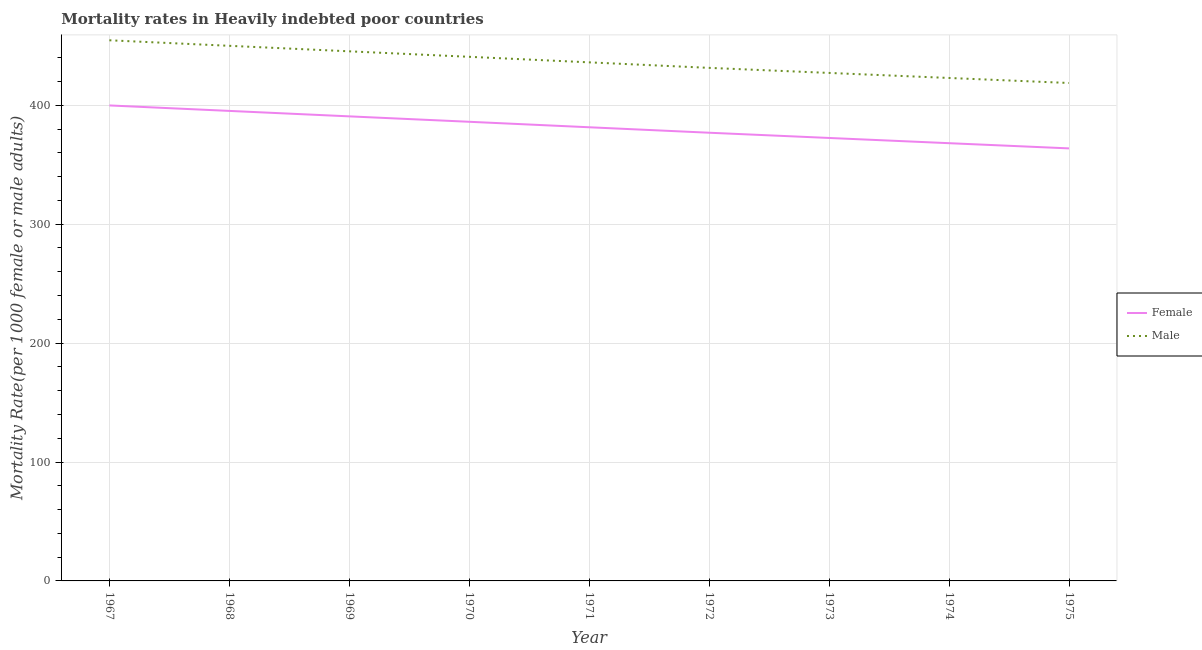Does the line corresponding to female mortality rate intersect with the line corresponding to male mortality rate?
Provide a succinct answer. No. Is the number of lines equal to the number of legend labels?
Keep it short and to the point. Yes. What is the female mortality rate in 1972?
Provide a short and direct response. 376.93. Across all years, what is the maximum female mortality rate?
Your answer should be compact. 399.88. Across all years, what is the minimum male mortality rate?
Give a very brief answer. 418.76. In which year was the male mortality rate maximum?
Your answer should be very brief. 1967. In which year was the male mortality rate minimum?
Offer a terse response. 1975. What is the total female mortality rate in the graph?
Offer a terse response. 3434.88. What is the difference between the female mortality rate in 1968 and that in 1975?
Keep it short and to the point. 31.52. What is the difference between the female mortality rate in 1974 and the male mortality rate in 1968?
Give a very brief answer. -81.89. What is the average male mortality rate per year?
Provide a succinct answer. 436.38. In the year 1968, what is the difference between the male mortality rate and female mortality rate?
Provide a short and direct response. 54.75. In how many years, is the male mortality rate greater than 380?
Your answer should be compact. 9. What is the ratio of the female mortality rate in 1970 to that in 1972?
Ensure brevity in your answer.  1.02. Is the difference between the female mortality rate in 1968 and 1974 greater than the difference between the male mortality rate in 1968 and 1974?
Provide a short and direct response. Yes. What is the difference between the highest and the second highest male mortality rate?
Provide a short and direct response. 4.65. What is the difference between the highest and the lowest male mortality rate?
Ensure brevity in your answer.  35.92. In how many years, is the female mortality rate greater than the average female mortality rate taken over all years?
Your answer should be compact. 4. Is the sum of the female mortality rate in 1969 and 1973 greater than the maximum male mortality rate across all years?
Your answer should be compact. Yes. Is the male mortality rate strictly greater than the female mortality rate over the years?
Provide a succinct answer. Yes. Is the female mortality rate strictly less than the male mortality rate over the years?
Provide a short and direct response. Yes. How many lines are there?
Ensure brevity in your answer.  2. How many years are there in the graph?
Ensure brevity in your answer.  9. Are the values on the major ticks of Y-axis written in scientific E-notation?
Provide a succinct answer. No. How are the legend labels stacked?
Your answer should be very brief. Vertical. What is the title of the graph?
Keep it short and to the point. Mortality rates in Heavily indebted poor countries. Does "Death rate" appear as one of the legend labels in the graph?
Ensure brevity in your answer.  No. What is the label or title of the X-axis?
Ensure brevity in your answer.  Year. What is the label or title of the Y-axis?
Give a very brief answer. Mortality Rate(per 1000 female or male adults). What is the Mortality Rate(per 1000 female or male adults) in Female in 1967?
Ensure brevity in your answer.  399.88. What is the Mortality Rate(per 1000 female or male adults) of Male in 1967?
Offer a very short reply. 454.68. What is the Mortality Rate(per 1000 female or male adults) in Female in 1968?
Your answer should be very brief. 395.28. What is the Mortality Rate(per 1000 female or male adults) of Male in 1968?
Offer a very short reply. 450.03. What is the Mortality Rate(per 1000 female or male adults) of Female in 1969?
Provide a short and direct response. 390.7. What is the Mortality Rate(per 1000 female or male adults) in Male in 1969?
Provide a short and direct response. 445.4. What is the Mortality Rate(per 1000 female or male adults) of Female in 1970?
Offer a terse response. 386.13. What is the Mortality Rate(per 1000 female or male adults) of Male in 1970?
Offer a terse response. 440.78. What is the Mortality Rate(per 1000 female or male adults) of Female in 1971?
Provide a succinct answer. 381.53. What is the Mortality Rate(per 1000 female or male adults) in Male in 1971?
Keep it short and to the point. 436.12. What is the Mortality Rate(per 1000 female or male adults) of Female in 1972?
Your answer should be compact. 376.93. What is the Mortality Rate(per 1000 female or male adults) of Male in 1972?
Provide a short and direct response. 431.48. What is the Mortality Rate(per 1000 female or male adults) in Female in 1973?
Provide a succinct answer. 372.53. What is the Mortality Rate(per 1000 female or male adults) of Male in 1973?
Keep it short and to the point. 427.22. What is the Mortality Rate(per 1000 female or male adults) of Female in 1974?
Offer a terse response. 368.14. What is the Mortality Rate(per 1000 female or male adults) in Male in 1974?
Provide a succinct answer. 422.99. What is the Mortality Rate(per 1000 female or male adults) of Female in 1975?
Offer a very short reply. 363.76. What is the Mortality Rate(per 1000 female or male adults) in Male in 1975?
Offer a terse response. 418.76. Across all years, what is the maximum Mortality Rate(per 1000 female or male adults) of Female?
Offer a terse response. 399.88. Across all years, what is the maximum Mortality Rate(per 1000 female or male adults) of Male?
Ensure brevity in your answer.  454.68. Across all years, what is the minimum Mortality Rate(per 1000 female or male adults) of Female?
Your answer should be compact. 363.76. Across all years, what is the minimum Mortality Rate(per 1000 female or male adults) of Male?
Ensure brevity in your answer.  418.76. What is the total Mortality Rate(per 1000 female or male adults) of Female in the graph?
Keep it short and to the point. 3434.88. What is the total Mortality Rate(per 1000 female or male adults) in Male in the graph?
Keep it short and to the point. 3927.45. What is the difference between the Mortality Rate(per 1000 female or male adults) in Male in 1967 and that in 1968?
Your response must be concise. 4.65. What is the difference between the Mortality Rate(per 1000 female or male adults) of Female in 1967 and that in 1969?
Ensure brevity in your answer.  9.18. What is the difference between the Mortality Rate(per 1000 female or male adults) in Male in 1967 and that in 1969?
Provide a succinct answer. 9.28. What is the difference between the Mortality Rate(per 1000 female or male adults) of Female in 1967 and that in 1970?
Your answer should be very brief. 13.75. What is the difference between the Mortality Rate(per 1000 female or male adults) in Male in 1967 and that in 1970?
Offer a very short reply. 13.9. What is the difference between the Mortality Rate(per 1000 female or male adults) of Female in 1967 and that in 1971?
Your response must be concise. 18.35. What is the difference between the Mortality Rate(per 1000 female or male adults) of Male in 1967 and that in 1971?
Offer a very short reply. 18.56. What is the difference between the Mortality Rate(per 1000 female or male adults) in Female in 1967 and that in 1972?
Make the answer very short. 22.95. What is the difference between the Mortality Rate(per 1000 female or male adults) in Male in 1967 and that in 1972?
Provide a succinct answer. 23.2. What is the difference between the Mortality Rate(per 1000 female or male adults) of Female in 1967 and that in 1973?
Provide a succinct answer. 27.35. What is the difference between the Mortality Rate(per 1000 female or male adults) of Male in 1967 and that in 1973?
Offer a very short reply. 27.45. What is the difference between the Mortality Rate(per 1000 female or male adults) of Female in 1967 and that in 1974?
Offer a terse response. 31.74. What is the difference between the Mortality Rate(per 1000 female or male adults) in Male in 1967 and that in 1974?
Offer a terse response. 31.69. What is the difference between the Mortality Rate(per 1000 female or male adults) in Female in 1967 and that in 1975?
Ensure brevity in your answer.  36.12. What is the difference between the Mortality Rate(per 1000 female or male adults) in Male in 1967 and that in 1975?
Ensure brevity in your answer.  35.92. What is the difference between the Mortality Rate(per 1000 female or male adults) in Female in 1968 and that in 1969?
Your answer should be compact. 4.58. What is the difference between the Mortality Rate(per 1000 female or male adults) in Male in 1968 and that in 1969?
Your response must be concise. 4.63. What is the difference between the Mortality Rate(per 1000 female or male adults) in Female in 1968 and that in 1970?
Ensure brevity in your answer.  9.15. What is the difference between the Mortality Rate(per 1000 female or male adults) of Male in 1968 and that in 1970?
Your response must be concise. 9.25. What is the difference between the Mortality Rate(per 1000 female or male adults) in Female in 1968 and that in 1971?
Provide a succinct answer. 13.75. What is the difference between the Mortality Rate(per 1000 female or male adults) of Male in 1968 and that in 1971?
Offer a very short reply. 13.9. What is the difference between the Mortality Rate(per 1000 female or male adults) of Female in 1968 and that in 1972?
Provide a short and direct response. 18.35. What is the difference between the Mortality Rate(per 1000 female or male adults) of Male in 1968 and that in 1972?
Make the answer very short. 18.55. What is the difference between the Mortality Rate(per 1000 female or male adults) of Female in 1968 and that in 1973?
Your answer should be very brief. 22.75. What is the difference between the Mortality Rate(per 1000 female or male adults) in Male in 1968 and that in 1973?
Provide a succinct answer. 22.8. What is the difference between the Mortality Rate(per 1000 female or male adults) in Female in 1968 and that in 1974?
Provide a short and direct response. 27.14. What is the difference between the Mortality Rate(per 1000 female or male adults) in Male in 1968 and that in 1974?
Your answer should be very brief. 27.04. What is the difference between the Mortality Rate(per 1000 female or male adults) in Female in 1968 and that in 1975?
Keep it short and to the point. 31.52. What is the difference between the Mortality Rate(per 1000 female or male adults) in Male in 1968 and that in 1975?
Offer a terse response. 31.27. What is the difference between the Mortality Rate(per 1000 female or male adults) in Female in 1969 and that in 1970?
Keep it short and to the point. 4.57. What is the difference between the Mortality Rate(per 1000 female or male adults) in Male in 1969 and that in 1970?
Provide a succinct answer. 4.61. What is the difference between the Mortality Rate(per 1000 female or male adults) in Female in 1969 and that in 1971?
Provide a succinct answer. 9.17. What is the difference between the Mortality Rate(per 1000 female or male adults) of Male in 1969 and that in 1971?
Provide a short and direct response. 9.27. What is the difference between the Mortality Rate(per 1000 female or male adults) in Female in 1969 and that in 1972?
Offer a terse response. 13.77. What is the difference between the Mortality Rate(per 1000 female or male adults) in Male in 1969 and that in 1972?
Your answer should be compact. 13.92. What is the difference between the Mortality Rate(per 1000 female or male adults) in Female in 1969 and that in 1973?
Ensure brevity in your answer.  18.17. What is the difference between the Mortality Rate(per 1000 female or male adults) of Male in 1969 and that in 1973?
Your answer should be very brief. 18.17. What is the difference between the Mortality Rate(per 1000 female or male adults) of Female in 1969 and that in 1974?
Provide a succinct answer. 22.56. What is the difference between the Mortality Rate(per 1000 female or male adults) of Male in 1969 and that in 1974?
Ensure brevity in your answer.  22.41. What is the difference between the Mortality Rate(per 1000 female or male adults) in Female in 1969 and that in 1975?
Offer a terse response. 26.94. What is the difference between the Mortality Rate(per 1000 female or male adults) of Male in 1969 and that in 1975?
Ensure brevity in your answer.  26.64. What is the difference between the Mortality Rate(per 1000 female or male adults) of Female in 1970 and that in 1971?
Give a very brief answer. 4.61. What is the difference between the Mortality Rate(per 1000 female or male adults) in Male in 1970 and that in 1971?
Give a very brief answer. 4.66. What is the difference between the Mortality Rate(per 1000 female or male adults) of Female in 1970 and that in 1972?
Offer a very short reply. 9.2. What is the difference between the Mortality Rate(per 1000 female or male adults) in Male in 1970 and that in 1972?
Offer a terse response. 9.3. What is the difference between the Mortality Rate(per 1000 female or male adults) of Female in 1970 and that in 1973?
Give a very brief answer. 13.6. What is the difference between the Mortality Rate(per 1000 female or male adults) of Male in 1970 and that in 1973?
Provide a short and direct response. 13.56. What is the difference between the Mortality Rate(per 1000 female or male adults) of Female in 1970 and that in 1974?
Provide a short and direct response. 17.99. What is the difference between the Mortality Rate(per 1000 female or male adults) in Male in 1970 and that in 1974?
Your answer should be very brief. 17.79. What is the difference between the Mortality Rate(per 1000 female or male adults) of Female in 1970 and that in 1975?
Provide a succinct answer. 22.38. What is the difference between the Mortality Rate(per 1000 female or male adults) of Male in 1970 and that in 1975?
Ensure brevity in your answer.  22.02. What is the difference between the Mortality Rate(per 1000 female or male adults) in Female in 1971 and that in 1972?
Provide a succinct answer. 4.59. What is the difference between the Mortality Rate(per 1000 female or male adults) in Male in 1971 and that in 1972?
Give a very brief answer. 4.64. What is the difference between the Mortality Rate(per 1000 female or male adults) in Female in 1971 and that in 1973?
Your response must be concise. 9. What is the difference between the Mortality Rate(per 1000 female or male adults) in Male in 1971 and that in 1973?
Your answer should be compact. 8.9. What is the difference between the Mortality Rate(per 1000 female or male adults) of Female in 1971 and that in 1974?
Offer a terse response. 13.39. What is the difference between the Mortality Rate(per 1000 female or male adults) of Male in 1971 and that in 1974?
Offer a terse response. 13.14. What is the difference between the Mortality Rate(per 1000 female or male adults) in Female in 1971 and that in 1975?
Your response must be concise. 17.77. What is the difference between the Mortality Rate(per 1000 female or male adults) in Male in 1971 and that in 1975?
Provide a short and direct response. 17.36. What is the difference between the Mortality Rate(per 1000 female or male adults) in Female in 1972 and that in 1973?
Keep it short and to the point. 4.4. What is the difference between the Mortality Rate(per 1000 female or male adults) in Male in 1972 and that in 1973?
Provide a short and direct response. 4.25. What is the difference between the Mortality Rate(per 1000 female or male adults) of Female in 1972 and that in 1974?
Make the answer very short. 8.79. What is the difference between the Mortality Rate(per 1000 female or male adults) in Male in 1972 and that in 1974?
Your answer should be compact. 8.49. What is the difference between the Mortality Rate(per 1000 female or male adults) in Female in 1972 and that in 1975?
Your answer should be very brief. 13.18. What is the difference between the Mortality Rate(per 1000 female or male adults) of Male in 1972 and that in 1975?
Your answer should be very brief. 12.72. What is the difference between the Mortality Rate(per 1000 female or male adults) in Female in 1973 and that in 1974?
Your answer should be very brief. 4.39. What is the difference between the Mortality Rate(per 1000 female or male adults) in Male in 1973 and that in 1974?
Give a very brief answer. 4.24. What is the difference between the Mortality Rate(per 1000 female or male adults) of Female in 1973 and that in 1975?
Make the answer very short. 8.77. What is the difference between the Mortality Rate(per 1000 female or male adults) of Male in 1973 and that in 1975?
Offer a terse response. 8.46. What is the difference between the Mortality Rate(per 1000 female or male adults) of Female in 1974 and that in 1975?
Your response must be concise. 4.38. What is the difference between the Mortality Rate(per 1000 female or male adults) in Male in 1974 and that in 1975?
Your answer should be very brief. 4.23. What is the difference between the Mortality Rate(per 1000 female or male adults) in Female in 1967 and the Mortality Rate(per 1000 female or male adults) in Male in 1968?
Give a very brief answer. -50.15. What is the difference between the Mortality Rate(per 1000 female or male adults) of Female in 1967 and the Mortality Rate(per 1000 female or male adults) of Male in 1969?
Give a very brief answer. -45.51. What is the difference between the Mortality Rate(per 1000 female or male adults) of Female in 1967 and the Mortality Rate(per 1000 female or male adults) of Male in 1970?
Your response must be concise. -40.9. What is the difference between the Mortality Rate(per 1000 female or male adults) in Female in 1967 and the Mortality Rate(per 1000 female or male adults) in Male in 1971?
Your answer should be compact. -36.24. What is the difference between the Mortality Rate(per 1000 female or male adults) of Female in 1967 and the Mortality Rate(per 1000 female or male adults) of Male in 1972?
Your answer should be very brief. -31.6. What is the difference between the Mortality Rate(per 1000 female or male adults) of Female in 1967 and the Mortality Rate(per 1000 female or male adults) of Male in 1973?
Provide a succinct answer. -27.34. What is the difference between the Mortality Rate(per 1000 female or male adults) in Female in 1967 and the Mortality Rate(per 1000 female or male adults) in Male in 1974?
Provide a succinct answer. -23.11. What is the difference between the Mortality Rate(per 1000 female or male adults) of Female in 1967 and the Mortality Rate(per 1000 female or male adults) of Male in 1975?
Keep it short and to the point. -18.88. What is the difference between the Mortality Rate(per 1000 female or male adults) of Female in 1968 and the Mortality Rate(per 1000 female or male adults) of Male in 1969?
Provide a succinct answer. -50.11. What is the difference between the Mortality Rate(per 1000 female or male adults) in Female in 1968 and the Mortality Rate(per 1000 female or male adults) in Male in 1970?
Your answer should be very brief. -45.5. What is the difference between the Mortality Rate(per 1000 female or male adults) of Female in 1968 and the Mortality Rate(per 1000 female or male adults) of Male in 1971?
Your answer should be very brief. -40.84. What is the difference between the Mortality Rate(per 1000 female or male adults) of Female in 1968 and the Mortality Rate(per 1000 female or male adults) of Male in 1972?
Make the answer very short. -36.2. What is the difference between the Mortality Rate(per 1000 female or male adults) in Female in 1968 and the Mortality Rate(per 1000 female or male adults) in Male in 1973?
Offer a terse response. -31.94. What is the difference between the Mortality Rate(per 1000 female or male adults) in Female in 1968 and the Mortality Rate(per 1000 female or male adults) in Male in 1974?
Your answer should be compact. -27.71. What is the difference between the Mortality Rate(per 1000 female or male adults) in Female in 1968 and the Mortality Rate(per 1000 female or male adults) in Male in 1975?
Give a very brief answer. -23.48. What is the difference between the Mortality Rate(per 1000 female or male adults) of Female in 1969 and the Mortality Rate(per 1000 female or male adults) of Male in 1970?
Give a very brief answer. -50.08. What is the difference between the Mortality Rate(per 1000 female or male adults) of Female in 1969 and the Mortality Rate(per 1000 female or male adults) of Male in 1971?
Offer a terse response. -45.42. What is the difference between the Mortality Rate(per 1000 female or male adults) of Female in 1969 and the Mortality Rate(per 1000 female or male adults) of Male in 1972?
Your answer should be very brief. -40.78. What is the difference between the Mortality Rate(per 1000 female or male adults) in Female in 1969 and the Mortality Rate(per 1000 female or male adults) in Male in 1973?
Offer a terse response. -36.53. What is the difference between the Mortality Rate(per 1000 female or male adults) of Female in 1969 and the Mortality Rate(per 1000 female or male adults) of Male in 1974?
Your response must be concise. -32.29. What is the difference between the Mortality Rate(per 1000 female or male adults) of Female in 1969 and the Mortality Rate(per 1000 female or male adults) of Male in 1975?
Provide a short and direct response. -28.06. What is the difference between the Mortality Rate(per 1000 female or male adults) in Female in 1970 and the Mortality Rate(per 1000 female or male adults) in Male in 1971?
Your answer should be compact. -49.99. What is the difference between the Mortality Rate(per 1000 female or male adults) of Female in 1970 and the Mortality Rate(per 1000 female or male adults) of Male in 1972?
Give a very brief answer. -45.35. What is the difference between the Mortality Rate(per 1000 female or male adults) in Female in 1970 and the Mortality Rate(per 1000 female or male adults) in Male in 1973?
Make the answer very short. -41.09. What is the difference between the Mortality Rate(per 1000 female or male adults) in Female in 1970 and the Mortality Rate(per 1000 female or male adults) in Male in 1974?
Your response must be concise. -36.85. What is the difference between the Mortality Rate(per 1000 female or male adults) of Female in 1970 and the Mortality Rate(per 1000 female or male adults) of Male in 1975?
Give a very brief answer. -32.63. What is the difference between the Mortality Rate(per 1000 female or male adults) of Female in 1971 and the Mortality Rate(per 1000 female or male adults) of Male in 1972?
Give a very brief answer. -49.95. What is the difference between the Mortality Rate(per 1000 female or male adults) of Female in 1971 and the Mortality Rate(per 1000 female or male adults) of Male in 1973?
Make the answer very short. -45.7. What is the difference between the Mortality Rate(per 1000 female or male adults) in Female in 1971 and the Mortality Rate(per 1000 female or male adults) in Male in 1974?
Make the answer very short. -41.46. What is the difference between the Mortality Rate(per 1000 female or male adults) in Female in 1971 and the Mortality Rate(per 1000 female or male adults) in Male in 1975?
Offer a terse response. -37.23. What is the difference between the Mortality Rate(per 1000 female or male adults) in Female in 1972 and the Mortality Rate(per 1000 female or male adults) in Male in 1973?
Offer a terse response. -50.29. What is the difference between the Mortality Rate(per 1000 female or male adults) in Female in 1972 and the Mortality Rate(per 1000 female or male adults) in Male in 1974?
Give a very brief answer. -46.05. What is the difference between the Mortality Rate(per 1000 female or male adults) of Female in 1972 and the Mortality Rate(per 1000 female or male adults) of Male in 1975?
Give a very brief answer. -41.83. What is the difference between the Mortality Rate(per 1000 female or male adults) of Female in 1973 and the Mortality Rate(per 1000 female or male adults) of Male in 1974?
Ensure brevity in your answer.  -50.46. What is the difference between the Mortality Rate(per 1000 female or male adults) in Female in 1973 and the Mortality Rate(per 1000 female or male adults) in Male in 1975?
Provide a short and direct response. -46.23. What is the difference between the Mortality Rate(per 1000 female or male adults) of Female in 1974 and the Mortality Rate(per 1000 female or male adults) of Male in 1975?
Your response must be concise. -50.62. What is the average Mortality Rate(per 1000 female or male adults) in Female per year?
Your answer should be compact. 381.65. What is the average Mortality Rate(per 1000 female or male adults) in Male per year?
Your answer should be compact. 436.38. In the year 1967, what is the difference between the Mortality Rate(per 1000 female or male adults) in Female and Mortality Rate(per 1000 female or male adults) in Male?
Make the answer very short. -54.8. In the year 1968, what is the difference between the Mortality Rate(per 1000 female or male adults) in Female and Mortality Rate(per 1000 female or male adults) in Male?
Keep it short and to the point. -54.75. In the year 1969, what is the difference between the Mortality Rate(per 1000 female or male adults) in Female and Mortality Rate(per 1000 female or male adults) in Male?
Your answer should be very brief. -54.7. In the year 1970, what is the difference between the Mortality Rate(per 1000 female or male adults) in Female and Mortality Rate(per 1000 female or male adults) in Male?
Provide a succinct answer. -54.65. In the year 1971, what is the difference between the Mortality Rate(per 1000 female or male adults) of Female and Mortality Rate(per 1000 female or male adults) of Male?
Ensure brevity in your answer.  -54.6. In the year 1972, what is the difference between the Mortality Rate(per 1000 female or male adults) in Female and Mortality Rate(per 1000 female or male adults) in Male?
Your answer should be compact. -54.55. In the year 1973, what is the difference between the Mortality Rate(per 1000 female or male adults) of Female and Mortality Rate(per 1000 female or male adults) of Male?
Your answer should be compact. -54.69. In the year 1974, what is the difference between the Mortality Rate(per 1000 female or male adults) of Female and Mortality Rate(per 1000 female or male adults) of Male?
Give a very brief answer. -54.85. In the year 1975, what is the difference between the Mortality Rate(per 1000 female or male adults) in Female and Mortality Rate(per 1000 female or male adults) in Male?
Keep it short and to the point. -55. What is the ratio of the Mortality Rate(per 1000 female or male adults) of Female in 1967 to that in 1968?
Ensure brevity in your answer.  1.01. What is the ratio of the Mortality Rate(per 1000 female or male adults) of Male in 1967 to that in 1968?
Your answer should be very brief. 1.01. What is the ratio of the Mortality Rate(per 1000 female or male adults) of Female in 1967 to that in 1969?
Give a very brief answer. 1.02. What is the ratio of the Mortality Rate(per 1000 female or male adults) in Male in 1967 to that in 1969?
Ensure brevity in your answer.  1.02. What is the ratio of the Mortality Rate(per 1000 female or male adults) in Female in 1967 to that in 1970?
Provide a succinct answer. 1.04. What is the ratio of the Mortality Rate(per 1000 female or male adults) of Male in 1967 to that in 1970?
Make the answer very short. 1.03. What is the ratio of the Mortality Rate(per 1000 female or male adults) of Female in 1967 to that in 1971?
Ensure brevity in your answer.  1.05. What is the ratio of the Mortality Rate(per 1000 female or male adults) of Male in 1967 to that in 1971?
Your answer should be very brief. 1.04. What is the ratio of the Mortality Rate(per 1000 female or male adults) of Female in 1967 to that in 1972?
Give a very brief answer. 1.06. What is the ratio of the Mortality Rate(per 1000 female or male adults) of Male in 1967 to that in 1972?
Your answer should be very brief. 1.05. What is the ratio of the Mortality Rate(per 1000 female or male adults) of Female in 1967 to that in 1973?
Offer a very short reply. 1.07. What is the ratio of the Mortality Rate(per 1000 female or male adults) of Male in 1967 to that in 1973?
Provide a succinct answer. 1.06. What is the ratio of the Mortality Rate(per 1000 female or male adults) of Female in 1967 to that in 1974?
Keep it short and to the point. 1.09. What is the ratio of the Mortality Rate(per 1000 female or male adults) in Male in 1967 to that in 1974?
Your response must be concise. 1.07. What is the ratio of the Mortality Rate(per 1000 female or male adults) in Female in 1967 to that in 1975?
Your answer should be very brief. 1.1. What is the ratio of the Mortality Rate(per 1000 female or male adults) in Male in 1967 to that in 1975?
Provide a short and direct response. 1.09. What is the ratio of the Mortality Rate(per 1000 female or male adults) of Female in 1968 to that in 1969?
Keep it short and to the point. 1.01. What is the ratio of the Mortality Rate(per 1000 female or male adults) in Male in 1968 to that in 1969?
Give a very brief answer. 1.01. What is the ratio of the Mortality Rate(per 1000 female or male adults) in Female in 1968 to that in 1970?
Offer a very short reply. 1.02. What is the ratio of the Mortality Rate(per 1000 female or male adults) in Male in 1968 to that in 1970?
Your answer should be compact. 1.02. What is the ratio of the Mortality Rate(per 1000 female or male adults) of Female in 1968 to that in 1971?
Provide a succinct answer. 1.04. What is the ratio of the Mortality Rate(per 1000 female or male adults) in Male in 1968 to that in 1971?
Offer a terse response. 1.03. What is the ratio of the Mortality Rate(per 1000 female or male adults) of Female in 1968 to that in 1972?
Make the answer very short. 1.05. What is the ratio of the Mortality Rate(per 1000 female or male adults) in Male in 1968 to that in 1972?
Offer a very short reply. 1.04. What is the ratio of the Mortality Rate(per 1000 female or male adults) of Female in 1968 to that in 1973?
Your response must be concise. 1.06. What is the ratio of the Mortality Rate(per 1000 female or male adults) of Male in 1968 to that in 1973?
Your response must be concise. 1.05. What is the ratio of the Mortality Rate(per 1000 female or male adults) in Female in 1968 to that in 1974?
Offer a very short reply. 1.07. What is the ratio of the Mortality Rate(per 1000 female or male adults) in Male in 1968 to that in 1974?
Give a very brief answer. 1.06. What is the ratio of the Mortality Rate(per 1000 female or male adults) in Female in 1968 to that in 1975?
Make the answer very short. 1.09. What is the ratio of the Mortality Rate(per 1000 female or male adults) in Male in 1968 to that in 1975?
Keep it short and to the point. 1.07. What is the ratio of the Mortality Rate(per 1000 female or male adults) in Female in 1969 to that in 1970?
Provide a succinct answer. 1.01. What is the ratio of the Mortality Rate(per 1000 female or male adults) in Male in 1969 to that in 1970?
Your answer should be very brief. 1.01. What is the ratio of the Mortality Rate(per 1000 female or male adults) in Female in 1969 to that in 1971?
Your answer should be very brief. 1.02. What is the ratio of the Mortality Rate(per 1000 female or male adults) in Male in 1969 to that in 1971?
Make the answer very short. 1.02. What is the ratio of the Mortality Rate(per 1000 female or male adults) in Female in 1969 to that in 1972?
Your answer should be compact. 1.04. What is the ratio of the Mortality Rate(per 1000 female or male adults) in Male in 1969 to that in 1972?
Give a very brief answer. 1.03. What is the ratio of the Mortality Rate(per 1000 female or male adults) in Female in 1969 to that in 1973?
Provide a succinct answer. 1.05. What is the ratio of the Mortality Rate(per 1000 female or male adults) of Male in 1969 to that in 1973?
Give a very brief answer. 1.04. What is the ratio of the Mortality Rate(per 1000 female or male adults) in Female in 1969 to that in 1974?
Offer a terse response. 1.06. What is the ratio of the Mortality Rate(per 1000 female or male adults) of Male in 1969 to that in 1974?
Provide a short and direct response. 1.05. What is the ratio of the Mortality Rate(per 1000 female or male adults) of Female in 1969 to that in 1975?
Keep it short and to the point. 1.07. What is the ratio of the Mortality Rate(per 1000 female or male adults) in Male in 1969 to that in 1975?
Provide a short and direct response. 1.06. What is the ratio of the Mortality Rate(per 1000 female or male adults) in Female in 1970 to that in 1971?
Offer a terse response. 1.01. What is the ratio of the Mortality Rate(per 1000 female or male adults) of Male in 1970 to that in 1971?
Offer a terse response. 1.01. What is the ratio of the Mortality Rate(per 1000 female or male adults) of Female in 1970 to that in 1972?
Offer a very short reply. 1.02. What is the ratio of the Mortality Rate(per 1000 female or male adults) in Male in 1970 to that in 1972?
Give a very brief answer. 1.02. What is the ratio of the Mortality Rate(per 1000 female or male adults) of Female in 1970 to that in 1973?
Provide a succinct answer. 1.04. What is the ratio of the Mortality Rate(per 1000 female or male adults) of Male in 1970 to that in 1973?
Your answer should be compact. 1.03. What is the ratio of the Mortality Rate(per 1000 female or male adults) in Female in 1970 to that in 1974?
Your answer should be very brief. 1.05. What is the ratio of the Mortality Rate(per 1000 female or male adults) in Male in 1970 to that in 1974?
Your answer should be compact. 1.04. What is the ratio of the Mortality Rate(per 1000 female or male adults) in Female in 1970 to that in 1975?
Ensure brevity in your answer.  1.06. What is the ratio of the Mortality Rate(per 1000 female or male adults) in Male in 1970 to that in 1975?
Keep it short and to the point. 1.05. What is the ratio of the Mortality Rate(per 1000 female or male adults) in Female in 1971 to that in 1972?
Your answer should be very brief. 1.01. What is the ratio of the Mortality Rate(per 1000 female or male adults) of Male in 1971 to that in 1972?
Ensure brevity in your answer.  1.01. What is the ratio of the Mortality Rate(per 1000 female or male adults) in Female in 1971 to that in 1973?
Your answer should be compact. 1.02. What is the ratio of the Mortality Rate(per 1000 female or male adults) in Male in 1971 to that in 1973?
Your response must be concise. 1.02. What is the ratio of the Mortality Rate(per 1000 female or male adults) of Female in 1971 to that in 1974?
Your answer should be compact. 1.04. What is the ratio of the Mortality Rate(per 1000 female or male adults) in Male in 1971 to that in 1974?
Your response must be concise. 1.03. What is the ratio of the Mortality Rate(per 1000 female or male adults) in Female in 1971 to that in 1975?
Your answer should be compact. 1.05. What is the ratio of the Mortality Rate(per 1000 female or male adults) in Male in 1971 to that in 1975?
Your answer should be very brief. 1.04. What is the ratio of the Mortality Rate(per 1000 female or male adults) of Female in 1972 to that in 1973?
Keep it short and to the point. 1.01. What is the ratio of the Mortality Rate(per 1000 female or male adults) of Female in 1972 to that in 1974?
Make the answer very short. 1.02. What is the ratio of the Mortality Rate(per 1000 female or male adults) of Male in 1972 to that in 1974?
Your answer should be compact. 1.02. What is the ratio of the Mortality Rate(per 1000 female or male adults) of Female in 1972 to that in 1975?
Offer a very short reply. 1.04. What is the ratio of the Mortality Rate(per 1000 female or male adults) of Male in 1972 to that in 1975?
Your answer should be very brief. 1.03. What is the ratio of the Mortality Rate(per 1000 female or male adults) in Female in 1973 to that in 1974?
Make the answer very short. 1.01. What is the ratio of the Mortality Rate(per 1000 female or male adults) in Female in 1973 to that in 1975?
Your response must be concise. 1.02. What is the ratio of the Mortality Rate(per 1000 female or male adults) in Male in 1973 to that in 1975?
Your answer should be very brief. 1.02. What is the ratio of the Mortality Rate(per 1000 female or male adults) in Female in 1974 to that in 1975?
Your answer should be compact. 1.01. What is the ratio of the Mortality Rate(per 1000 female or male adults) of Male in 1974 to that in 1975?
Provide a succinct answer. 1.01. What is the difference between the highest and the second highest Mortality Rate(per 1000 female or male adults) of Male?
Your answer should be compact. 4.65. What is the difference between the highest and the lowest Mortality Rate(per 1000 female or male adults) of Female?
Provide a succinct answer. 36.12. What is the difference between the highest and the lowest Mortality Rate(per 1000 female or male adults) in Male?
Provide a short and direct response. 35.92. 